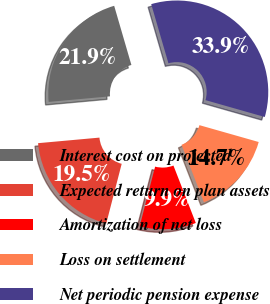<chart> <loc_0><loc_0><loc_500><loc_500><pie_chart><fcel>Interest cost on projected<fcel>Expected return on plan assets<fcel>Amortization of net loss<fcel>Loss on settlement<fcel>Net periodic pension expense<nl><fcel>21.93%<fcel>19.53%<fcel>9.94%<fcel>14.68%<fcel>33.92%<nl></chart> 